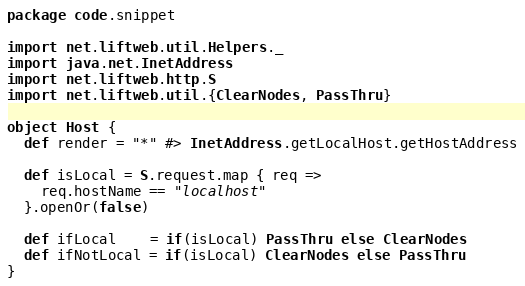<code> <loc_0><loc_0><loc_500><loc_500><_Scala_>package code.snippet

import net.liftweb.util.Helpers._
import java.net.InetAddress
import net.liftweb.http.S
import net.liftweb.util.{ClearNodes, PassThru}

object Host {
  def render = "*" #> InetAddress.getLocalHost.getHostAddress

  def isLocal = S.request.map { req =>
    req.hostName == "localhost"
  }.openOr(false)

  def ifLocal    = if(isLocal) PassThru else ClearNodes
  def ifNotLocal = if(isLocal) ClearNodes else PassThru
}
</code> 